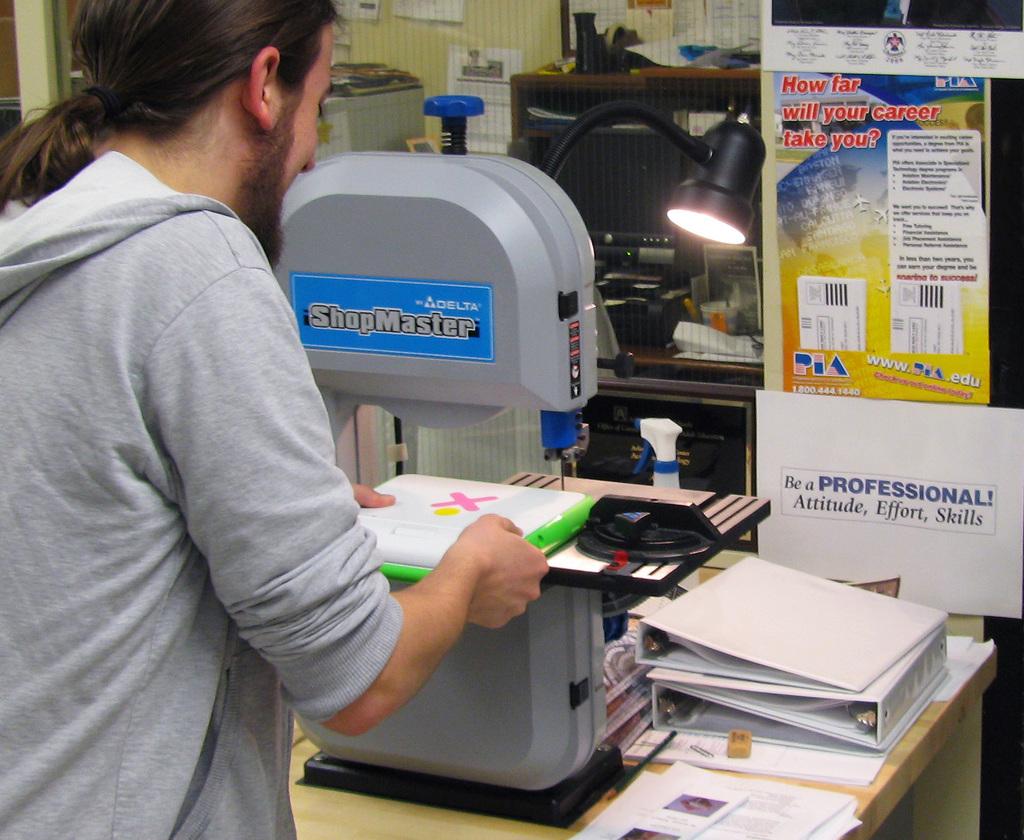What three things make one a professional?
Your answer should be compact. Attitude, effort, skills. What is the name of the machine in the blue box?
Offer a terse response. Shopmaster. 